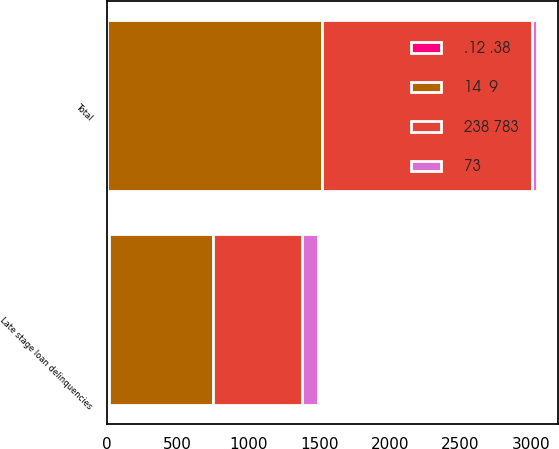Convert chart. <chart><loc_0><loc_0><loc_500><loc_500><stacked_bar_chart><ecel><fcel>Late stage loan delinquencies<fcel>Total<nl><fcel>238 783<fcel>629<fcel>1485<nl><fcel>14  9<fcel>737<fcel>1520<nl><fcel>73<fcel>108<fcel>35<nl><fcel>.12 .38<fcel>15<fcel>2<nl></chart> 